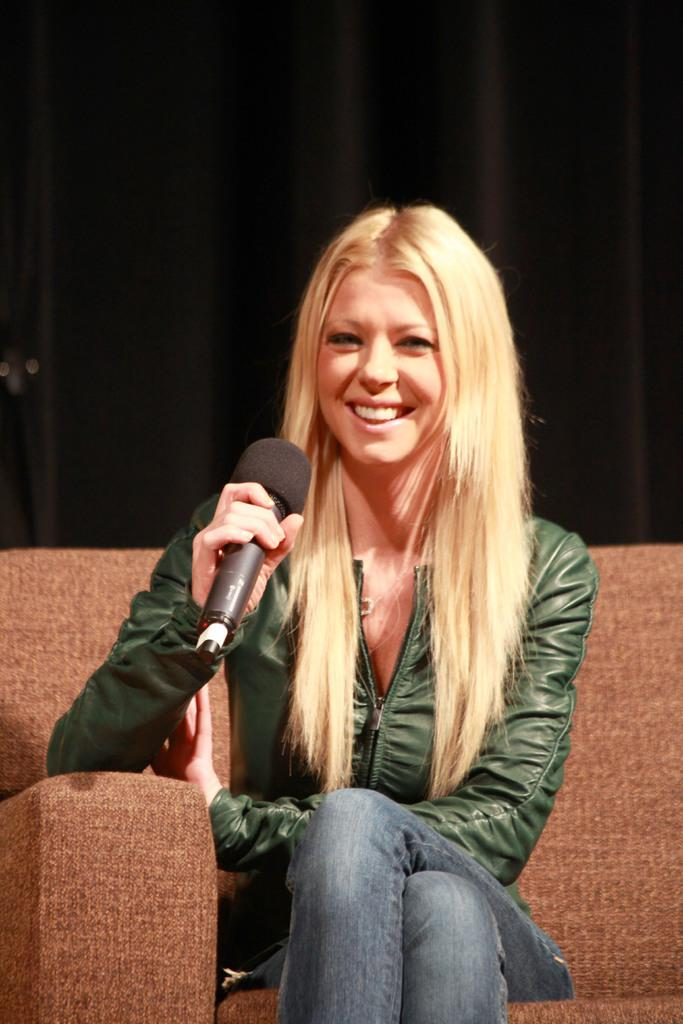Who is the main subject in the image? There is a woman in the image. Can you describe the woman's appearance? The woman has blond hair. What is the woman doing in the image? The woman is sitting on a sofa and holding a microphone. What is the woman's expression in the image? The woman is smiling. How many trees can be seen in the image? There are no trees visible in the image; it features a woman sitting on a sofa and holding a microphone. What type of shoes is the woman wearing, and can you see her toes? The image does not show the woman's shoes or toes, as it focuses on her upper body and the microphone she is holding. 